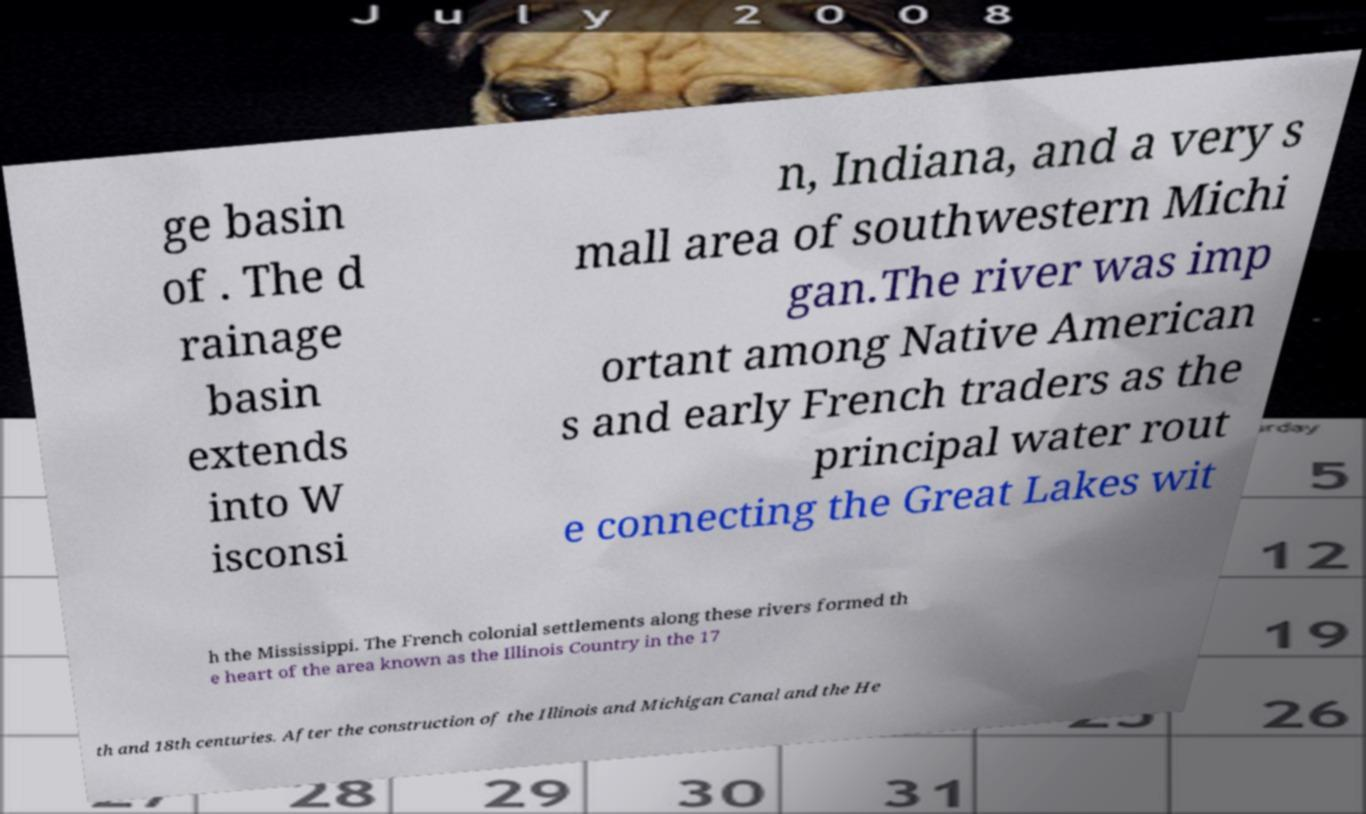There's text embedded in this image that I need extracted. Can you transcribe it verbatim? ge basin of . The d rainage basin extends into W isconsi n, Indiana, and a very s mall area of southwestern Michi gan.The river was imp ortant among Native American s and early French traders as the principal water rout e connecting the Great Lakes wit h the Mississippi. The French colonial settlements along these rivers formed th e heart of the area known as the Illinois Country in the 17 th and 18th centuries. After the construction of the Illinois and Michigan Canal and the He 